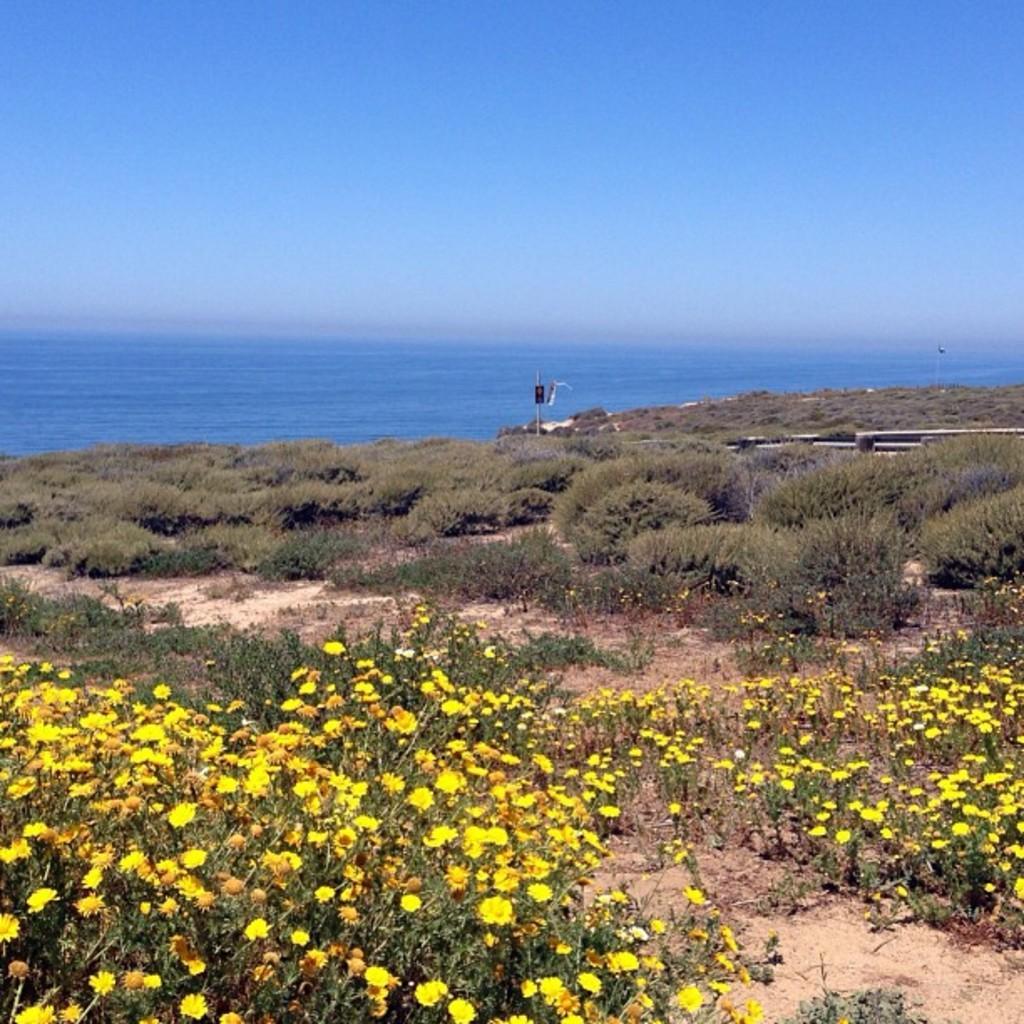Can you describe this image briefly? In this picture we can see plants with flowers on the ground and in the background we can see the sea and the sky. 